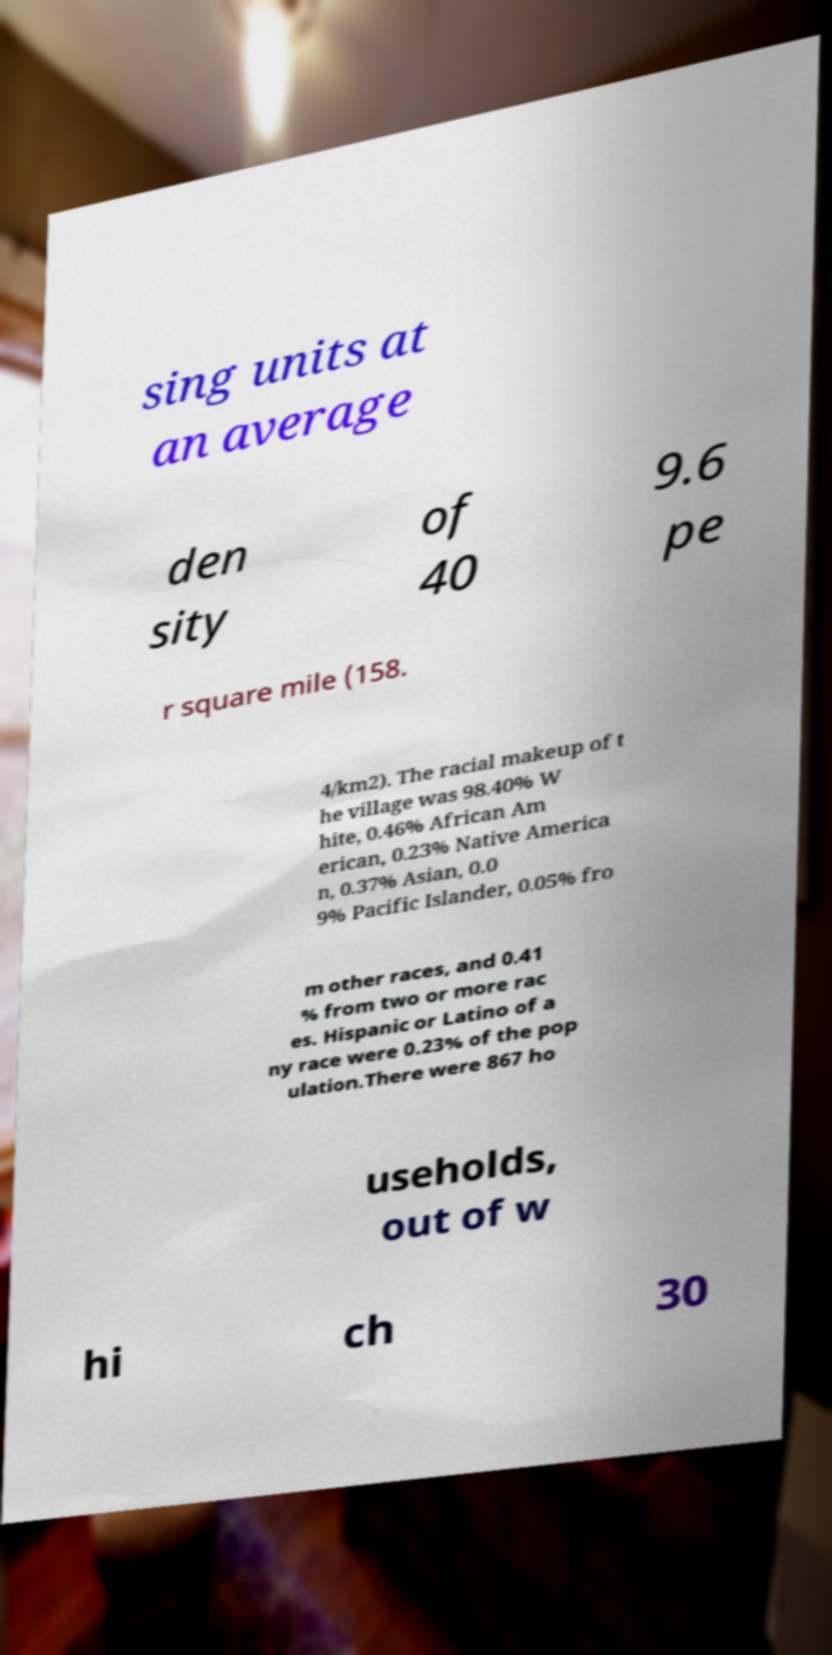Could you assist in decoding the text presented in this image and type it out clearly? sing units at an average den sity of 40 9.6 pe r square mile (158. 4/km2). The racial makeup of t he village was 98.40% W hite, 0.46% African Am erican, 0.23% Native America n, 0.37% Asian, 0.0 9% Pacific Islander, 0.05% fro m other races, and 0.41 % from two or more rac es. Hispanic or Latino of a ny race were 0.23% of the pop ulation.There were 867 ho useholds, out of w hi ch 30 